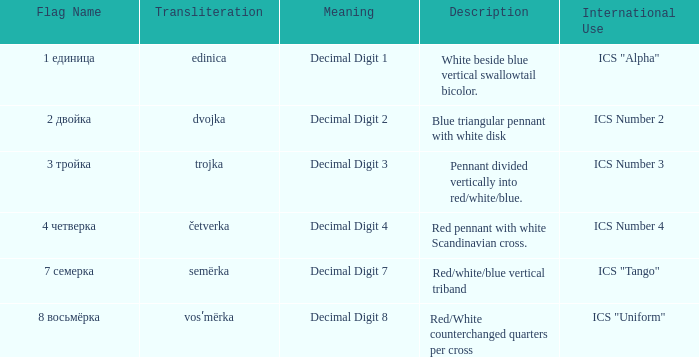What are the significances of the flag with a name that transliterates to dvojka? Decimal Digit 2. 